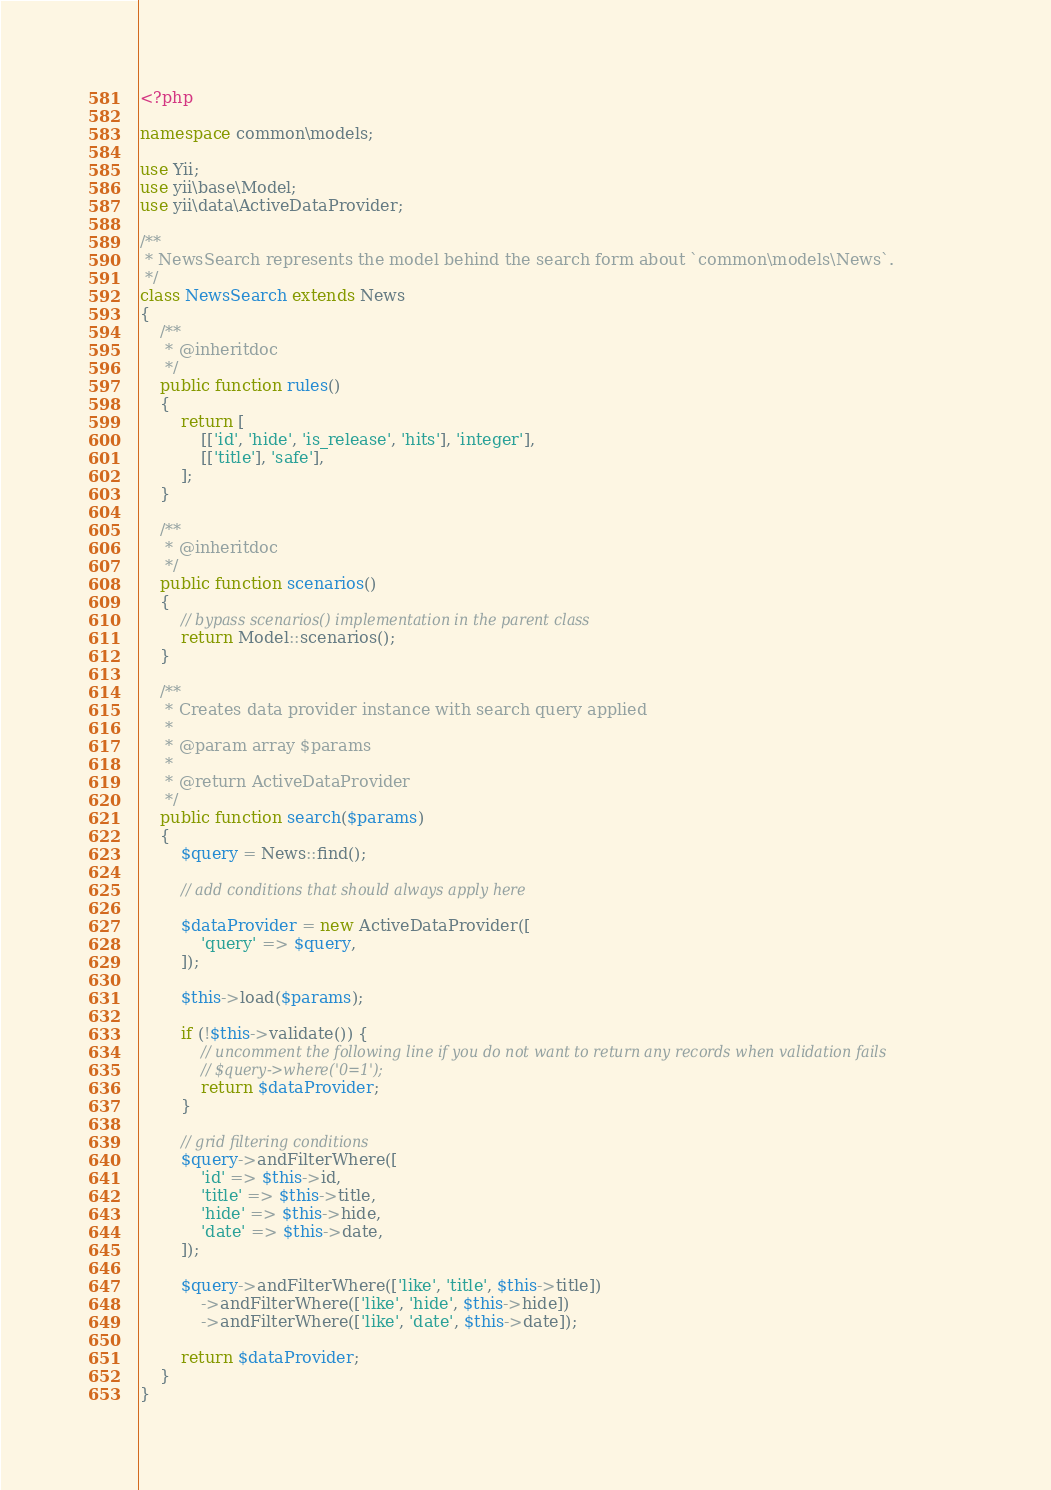Convert code to text. <code><loc_0><loc_0><loc_500><loc_500><_PHP_><?php

namespace common\models;

use Yii;
use yii\base\Model;
use yii\data\ActiveDataProvider;

/**
 * NewsSearch represents the model behind the search form about `common\models\News`.
 */
class NewsSearch extends News
{
    /**
     * @inheritdoc
     */
    public function rules()
    {
        return [
            [['id', 'hide', 'is_release', 'hits'], 'integer'],
            [['title'], 'safe'],
        ];
    }

    /**
     * @inheritdoc
     */
    public function scenarios()
    {
        // bypass scenarios() implementation in the parent class
        return Model::scenarios();
    }

    /**
     * Creates data provider instance with search query applied
     *
     * @param array $params
     *
     * @return ActiveDataProvider
     */
    public function search($params)
    {
        $query = News::find();

        // add conditions that should always apply here

        $dataProvider = new ActiveDataProvider([
            'query' => $query,
        ]);

        $this->load($params);

        if (!$this->validate()) {
            // uncomment the following line if you do not want to return any records when validation fails
            // $query->where('0=1');
            return $dataProvider;
        }

        // grid filtering conditions
        $query->andFilterWhere([
            'id' => $this->id,
            'title' => $this->title,
            'hide' => $this->hide,
            'date' => $this->date,
        ]);

        $query->andFilterWhere(['like', 'title', $this->title])
            ->andFilterWhere(['like', 'hide', $this->hide])
            ->andFilterWhere(['like', 'date', $this->date]);

        return $dataProvider;
    }
}
</code> 